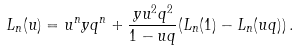<formula> <loc_0><loc_0><loc_500><loc_500>L _ { n } ( u ) = u ^ { n } y q ^ { n } + \frac { y u ^ { 2 } q ^ { 2 } } { 1 - u q } ( L _ { n } ( 1 ) - L _ { n } ( u q ) ) \, .</formula> 